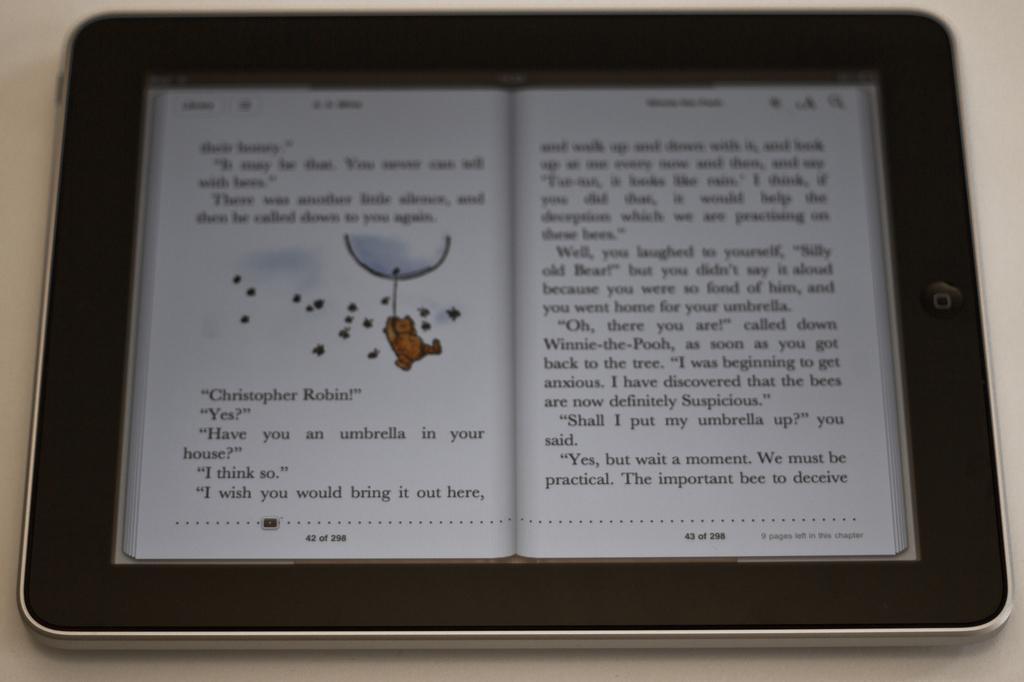<image>
Summarize the visual content of the image. A kindle with an open edition of Winnie the Pooh with the first words being 'their honey' 